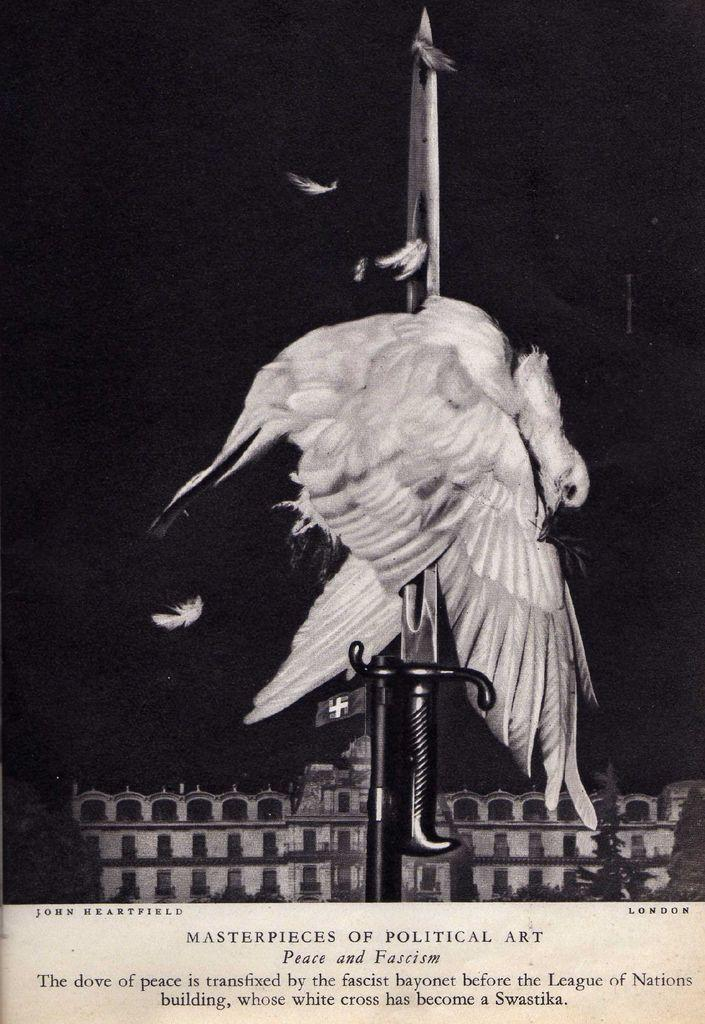<image>
Write a terse but informative summary of the picture. A bird hangs upside down on a sword under a label that says Masterpieces of Political Art. 